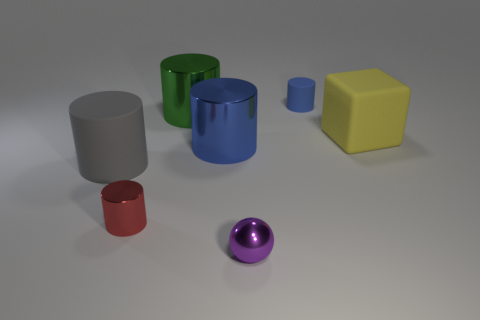What could be the function of these objects in real-life applications? These objects, due to their simple geometric shapes, might serve educational purposes for teaching geometry. In a real-life context, they could also be design elements in a game, placeholders in 3D modeling software, or part of a visual arts composition. 